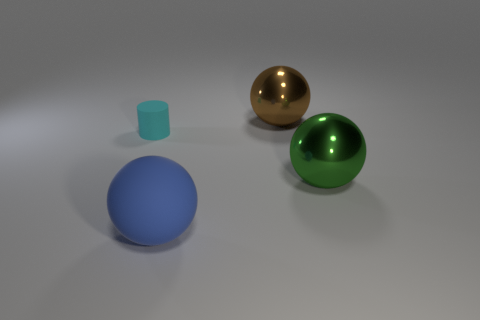What color is the large metal sphere that is on the left side of the big ball that is right of the big brown ball?
Give a very brief answer. Brown. How many tiny cyan rubber cylinders are there?
Provide a succinct answer. 1. How many matte things are either tiny things or gray objects?
Offer a terse response. 1. How many big shiny things have the same color as the large rubber thing?
Your response must be concise. 0. What is the material of the ball that is to the right of the big object that is behind the green shiny object?
Your answer should be compact. Metal. The matte sphere has what size?
Ensure brevity in your answer.  Large. What number of brown metallic spheres are the same size as the cyan cylinder?
Ensure brevity in your answer.  0. What number of big green metallic objects are the same shape as the brown object?
Provide a succinct answer. 1. Are there an equal number of large shiny things behind the green ball and rubber cylinders?
Your answer should be compact. Yes. Are there any other things that are the same size as the matte cylinder?
Your response must be concise. No. 